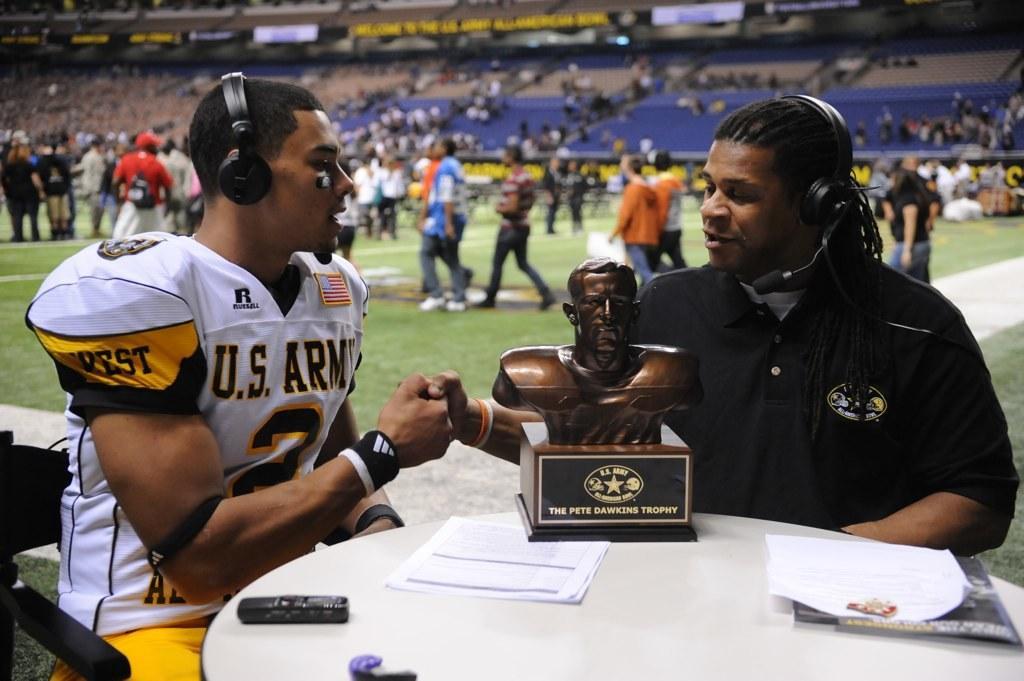Could you give a brief overview of what you see in this image? In this image we can see a stadium. There are many people in the image. There are two people sitting on the chair. There is a trophy and few other objects on the table. 